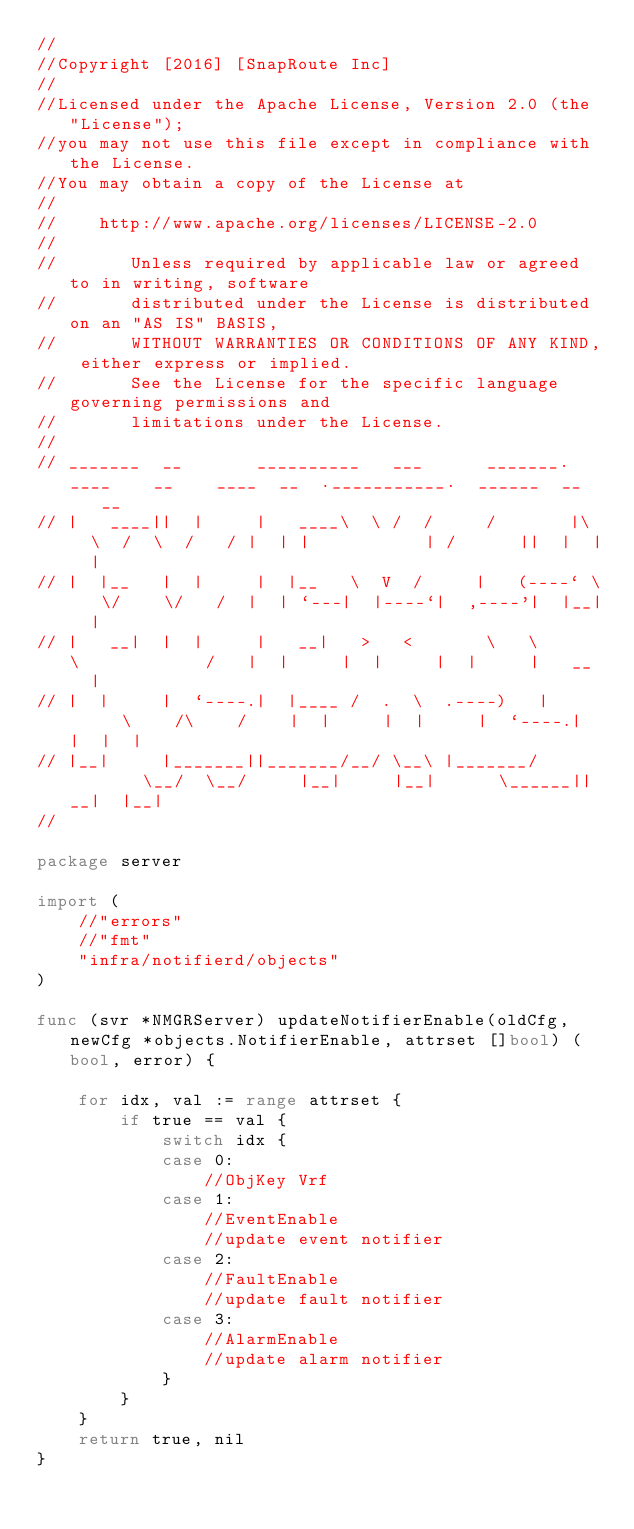Convert code to text. <code><loc_0><loc_0><loc_500><loc_500><_Go_>//
//Copyright [2016] [SnapRoute Inc]
//
//Licensed under the Apache License, Version 2.0 (the "License");
//you may not use this file except in compliance with the License.
//You may obtain a copy of the License at
//
//    http://www.apache.org/licenses/LICENSE-2.0
//
//       Unless required by applicable law or agreed to in writing, software
//       distributed under the License is distributed on an "AS IS" BASIS,
//       WITHOUT WARRANTIES OR CONDITIONS OF ANY KIND, either express or implied.
//       See the License for the specific language governing permissions and
//       limitations under the License.
//
// _______  __       __________   ___      _______.____    __    ____  __  .___________.  ______  __    __
// |   ____||  |     |   ____\  \ /  /     /       |\   \  /  \  /   / |  | |           | /      ||  |  |  |
// |  |__   |  |     |  |__   \  V  /     |   (----` \   \/    \/   /  |  | `---|  |----`|  ,----'|  |__|  |
// |   __|  |  |     |   __|   >   <       \   \      \            /   |  |     |  |     |  |     |   __   |
// |  |     |  `----.|  |____ /  .  \  .----)   |      \    /\    /    |  |     |  |     |  `----.|  |  |  |
// |__|     |_______||_______/__/ \__\ |_______/        \__/  \__/     |__|     |__|      \______||__|  |__|
//

package server

import (
	//"errors"
	//"fmt"
	"infra/notifierd/objects"
)

func (svr *NMGRServer) updateNotifierEnable(oldCfg, newCfg *objects.NotifierEnable, attrset []bool) (bool, error) {

	for idx, val := range attrset {
		if true == val {
			switch idx {
			case 0:
				//ObjKey Vrf
			case 1:
				//EventEnable
				//update event notifier
			case 2:
				//FaultEnable
				//update fault notifier
			case 3:
				//AlarmEnable
				//update alarm notifier
			}
		}
	}
	return true, nil
}
</code> 